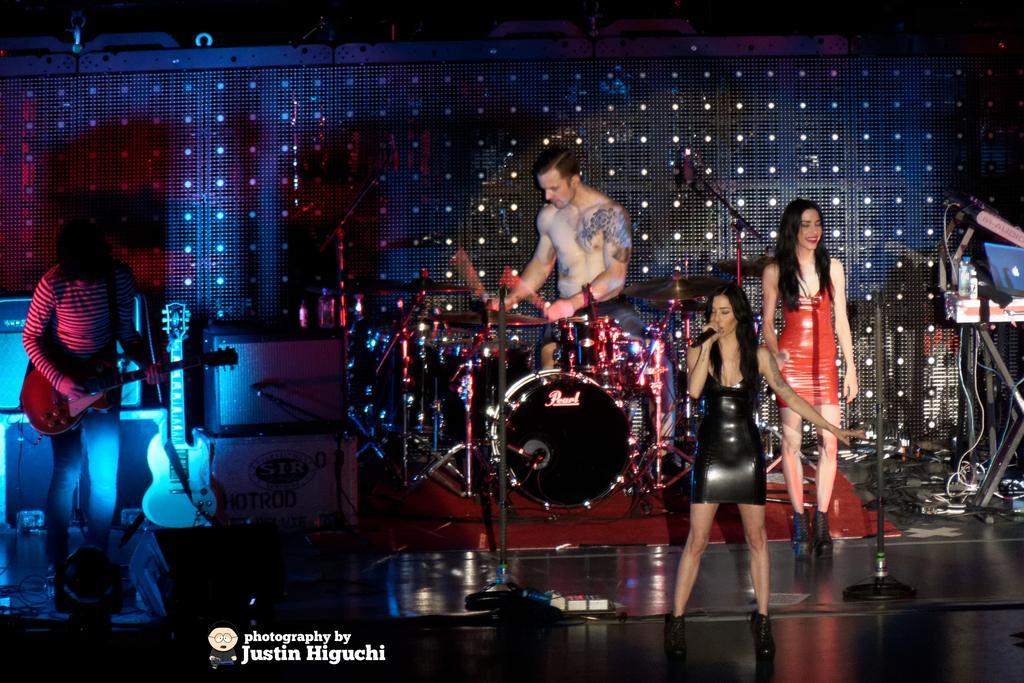How would you summarize this image in a sentence or two? In this picture we can see two persons playing musical instrument such as guitar and drums and woman singing on mic and other woman is standing and smiling on stage and in background we can see wall. 